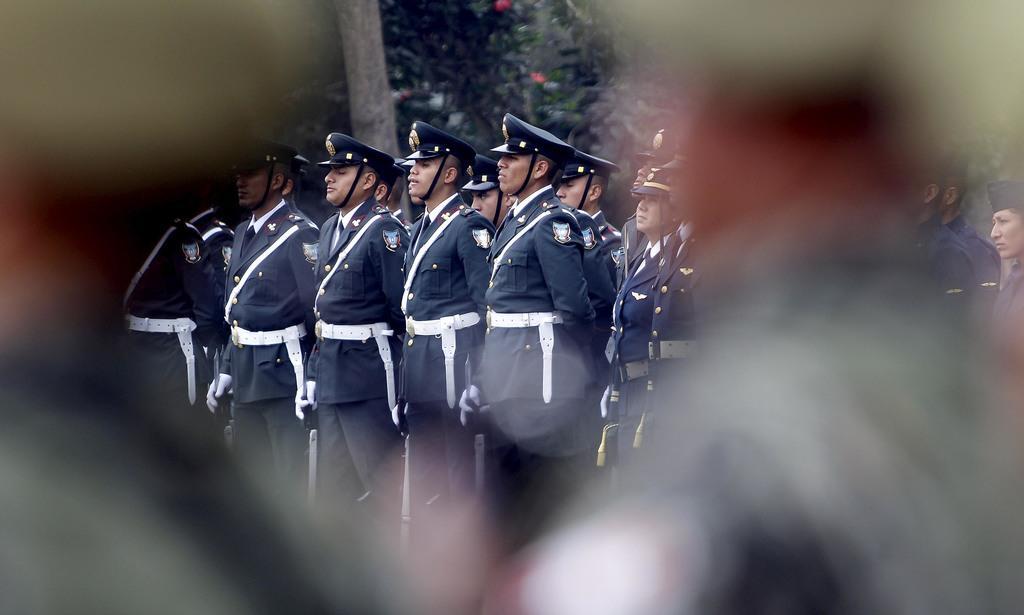Can you describe this image briefly? In this image we can see people standing wearing uniforms. In the background of the image there are trees. 